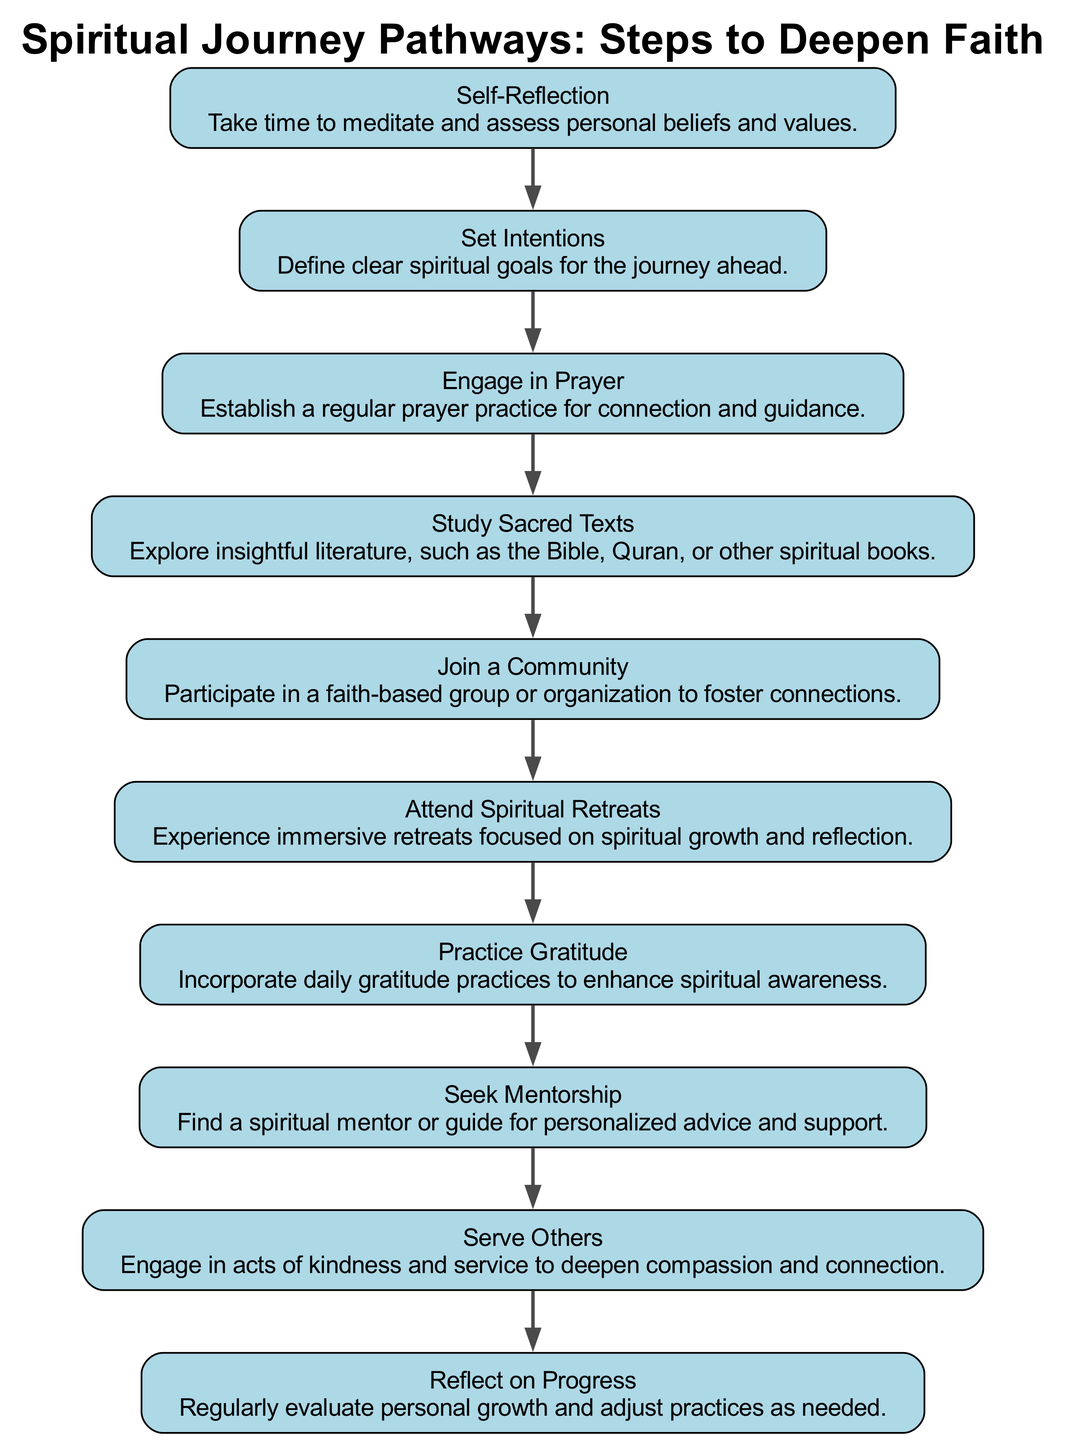What is the first step in the spiritual journey pathway? The first step is identified by looking at the top node of the diagram. Since the flow is directed from top to bottom, the first node listed is "Self-Reflection."
Answer: Self-Reflection What are the last three steps in the diagram? The last three nodes can be found by looking at the bottom portion of the flowchart. These nodes are "Serve Others," "Reflect on Progress," and "Seek Mentorship."
Answer: Serve Others, Reflect on Progress, Seek Mentorship How many steps are there in total? The total number of steps is counted by counting all individual nodes in the diagram. There are ten distinct steps listed.
Answer: 10 Which step directly follows "Join a Community"? By following the flow from the node "Join a Community," the next node is "Attend Spiritual Retreats." This indicates the immediate progression in the journey pathway.
Answer: Attend Spiritual Retreats What is the relationship between "Practice Gratitude" and "Engage in Prayer"? "Practice Gratitude" and "Engage in Prayer" are both steps in the journey, but "Engage in Prayer" precedes "Practice Gratitude." The relationship is a sequence where one step leads to the next in the flowchart.
Answer: Engage in Prayer precedes Practice Gratitude What is the step describing an action to deepen compassion? The node that pertains to deepening compassion is analyzed by reading through the descriptions. The step "Serve Others" specifically mentions engaging in acts of kindness and service.
Answer: Serve Others What is the step that emphasizes personal evaluation? "Reflect on Progress" highlights the importance of regular evaluation of personal growth and adjusting practices based on that reflection.
Answer: Reflect on Progress Which two steps could be considered as foundational steps in the journey? By examining the nodes, "Self-Reflection" and "Set Intentions" are foundational as they help establish the core values and goals necessary for the journey ahead.
Answer: Self-Reflection, Set Intentions What is a recommended action to foster connections with others? The step "Join a Community" directly suggests participating in a faith-based group or organization as a means to foster connections with others.
Answer: Join a Community 